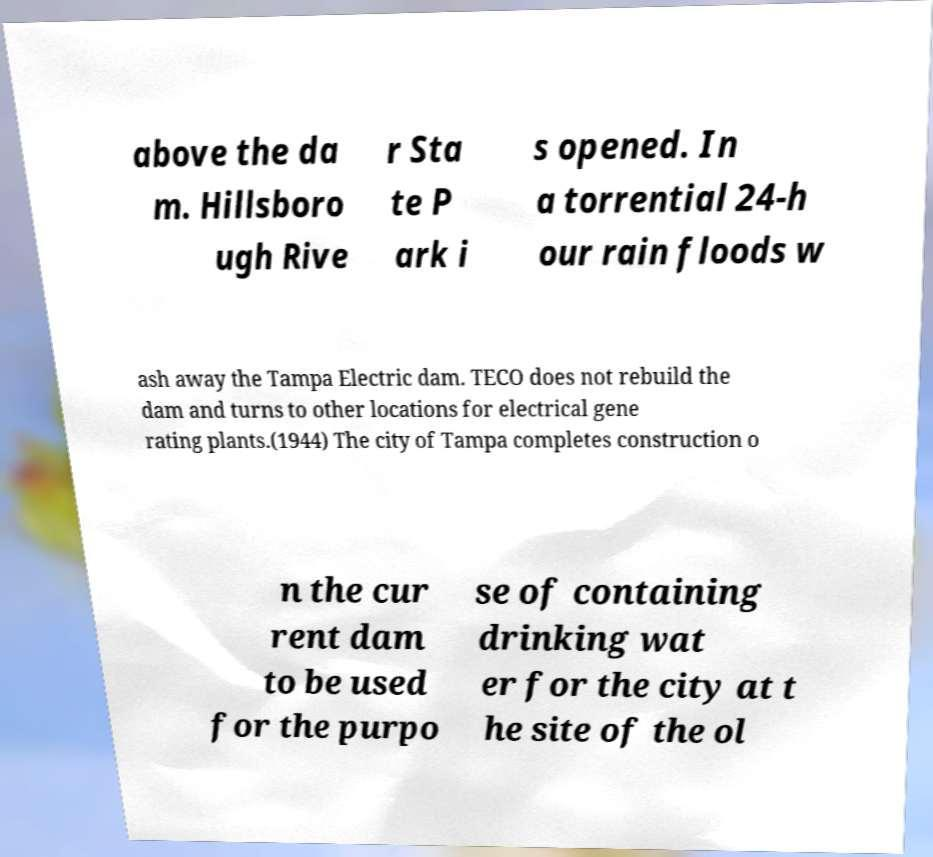Can you read and provide the text displayed in the image?This photo seems to have some interesting text. Can you extract and type it out for me? above the da m. Hillsboro ugh Rive r Sta te P ark i s opened. In a torrential 24-h our rain floods w ash away the Tampa Electric dam. TECO does not rebuild the dam and turns to other locations for electrical gene rating plants.(1944) The city of Tampa completes construction o n the cur rent dam to be used for the purpo se of containing drinking wat er for the city at t he site of the ol 